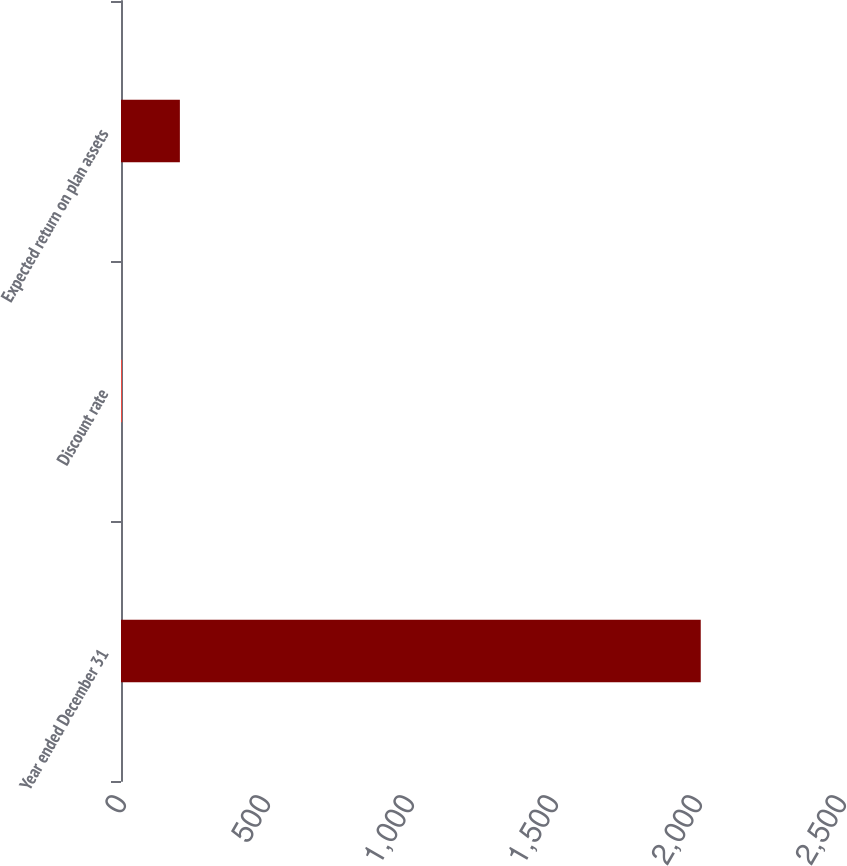Convert chart. <chart><loc_0><loc_0><loc_500><loc_500><bar_chart><fcel>Year ended December 31<fcel>Discount rate<fcel>Expected return on plan assets<nl><fcel>2013<fcel>3.5<fcel>204.45<nl></chart> 